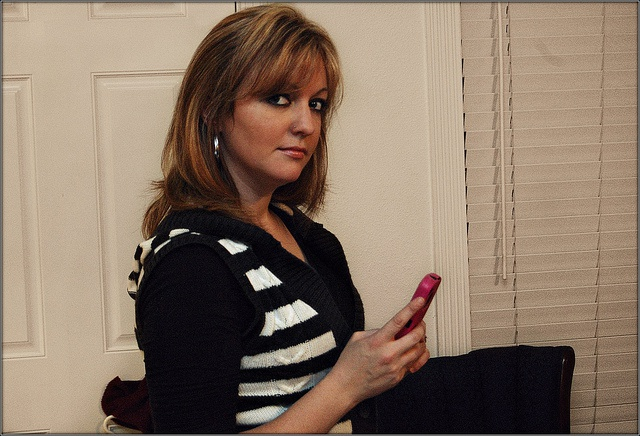Describe the objects in this image and their specific colors. I can see people in black, maroon, and gray tones and cell phone in black, maroon, and brown tones in this image. 